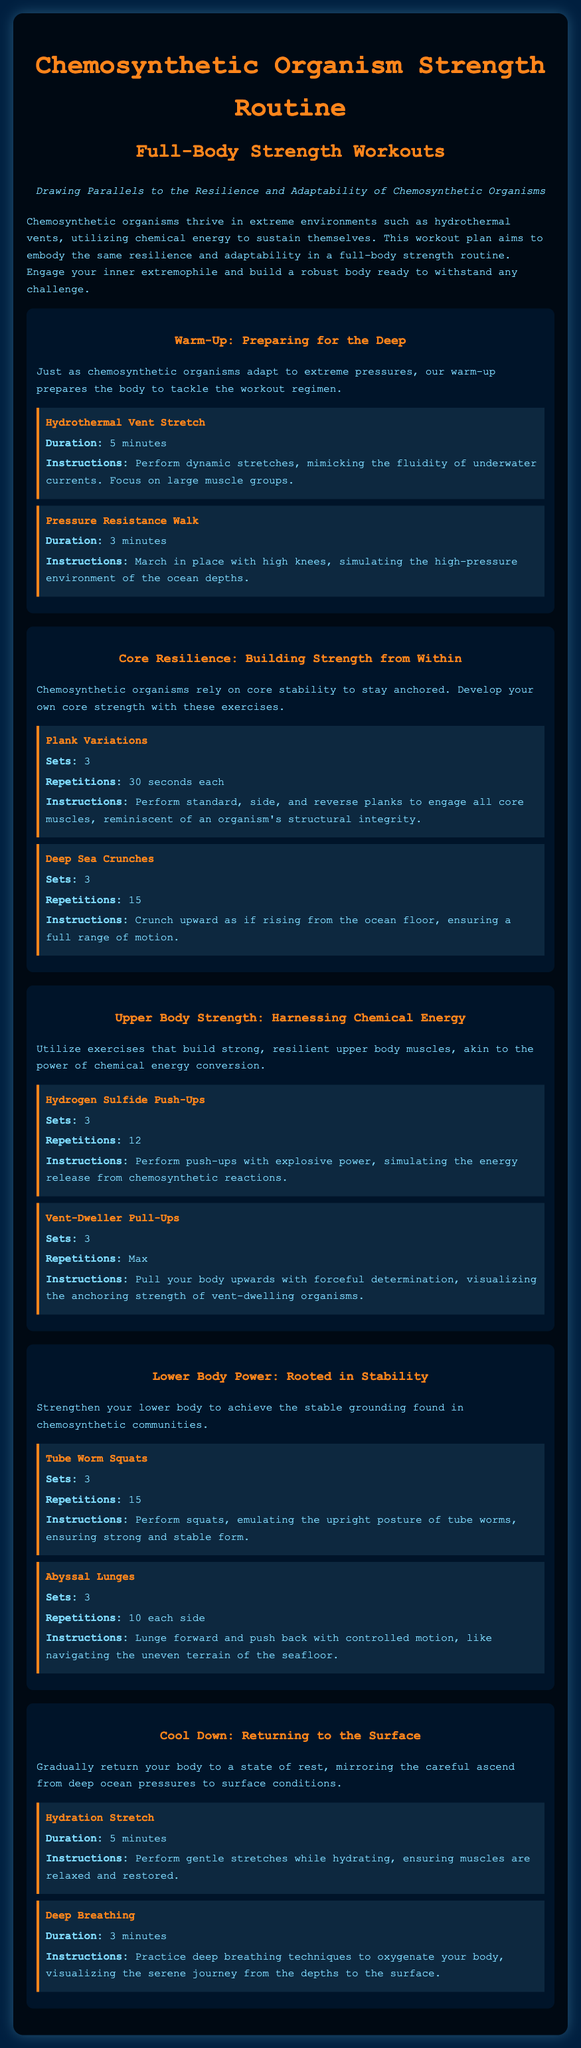What is the title of the workout plan? The title of the workout plan is presented at the top of the document as "Chemosynthetic Organism Strength Routine."
Answer: Chemosynthetic Organism Strength Routine How many sets are recommended for Deep Sea Crunches? The document states that 3 sets are recommended for Deep Sea Crunches.
Answer: 3 What exercise begins the cool down section? The first exercise in the cool down section is referred to as "Hydration Stretch."
Answer: Hydration Stretch How long should the Hydrogen Sulfide Push-Ups be performed for each set? The document specifies that 12 repetitions should be performed for each set of Hydrogen Sulfide Push-Ups.
Answer: 12 What is the purpose of the warm-up section? The warm-up section prepares the body to tackle the workout regimen, just like chemosynthetic organisms adapt to extreme pressures.
Answer: Prepare the body Which lower body exercise is modeled after tube worms? The exercise is called "Tube Worm Squats," which is modeled after the posture of tube worms.
Answer: Tube Worm Squats How long should the Pressure Resistance Walk last? The document indicates that the Pressure Resistance Walk should last for 3 minutes.
Answer: 3 minutes What key theme is emphasized throughout the workout plan? The workout plan emphasizes resilience and adaptability as key themes throughout the exercises, analogous to chemosynthetic organisms.
Answer: Resilience and adaptability 